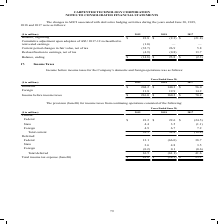According to Carpenter Technology's financial document, What was the amount of Income before income taxes in 2019? According to the financial document, $216.0 (in millions). The relevant text states: "reign 11.8 19.9 14.2 Income before income taxes $ 216.0 $ 160.2 $ 70.2..." Also, What was the amount of  Domestic  Income before income taxes in 2018? According to the financial document, $140.3 (in millions). The relevant text states: "($ in millions) 2019 2018 2017 Domestic $ 204.2 $ 140.3 $ 56.0 Foreign 11.8 19.9 14.2 Income before income taxes $ 216.0 $ 160.2 $ 70.2..." Also, What are the different types of operations for which income before income taxes was provided? The document shows two values: Domestic and Foreign. From the document: "Income before income taxes for the Company’s domestic and foreign operations was as follows: s) 2019 2018 2017 Domestic $ 204.2 $ 140.3 $ 56.0 Foreign..." Additionally, In which year was Foreign largest? According to the financial document, 2018. The relevant text states: "($ in millions) 2019 2018 2017 Balance, beginning $ 23.8 $ (2.3) $ (21.8) Cumulative adjustment upon adoption of ASU 2017-12..." Also, can you calculate: What was the change in Foreign in 2019 from 2018? Based on the calculation: 11.8-19.9, the result is -8.1 (in millions). This is based on the information: "2017 Domestic $ 204.2 $ 140.3 $ 56.0 Foreign 11.8 19.9 14.2 Income before income taxes $ 216.0 $ 160.2 $ 70.2 2018 2017 Domestic $ 204.2 $ 140.3 $ 56.0 Foreign 11.8 19.9 14.2 Income before income taxe..." The key data points involved are: 11.8, 19.9. Also, can you calculate: What was the percentage change in Foreign in 2019 from 2018? To answer this question, I need to perform calculations using the financial data. The calculation is: (11.8-19.9)/19.9, which equals -40.7 (percentage). This is based on the information: "2017 Domestic $ 204.2 $ 140.3 $ 56.0 Foreign 11.8 19.9 14.2 Income before income taxes $ 216.0 $ 160.2 $ 70.2 2018 2017 Domestic $ 204.2 $ 140.3 $ 56.0 Foreign 11.8 19.9 14.2 Income before income taxe..." The key data points involved are: 11.8, 19.9. 